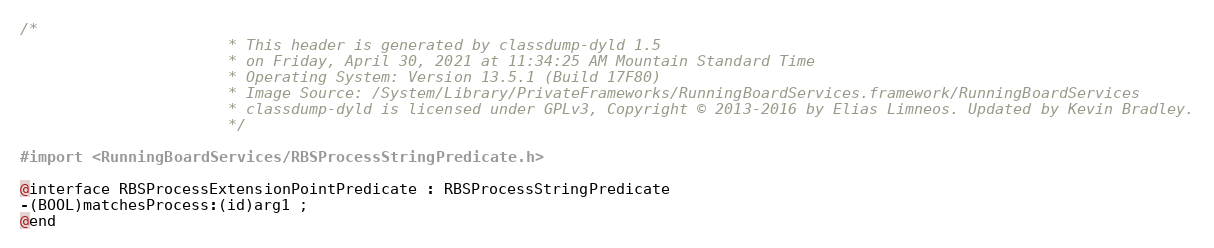<code> <loc_0><loc_0><loc_500><loc_500><_C_>/*
                       * This header is generated by classdump-dyld 1.5
                       * on Friday, April 30, 2021 at 11:34:25 AM Mountain Standard Time
                       * Operating System: Version 13.5.1 (Build 17F80)
                       * Image Source: /System/Library/PrivateFrameworks/RunningBoardServices.framework/RunningBoardServices
                       * classdump-dyld is licensed under GPLv3, Copyright © 2013-2016 by Elias Limneos. Updated by Kevin Bradley.
                       */

#import <RunningBoardServices/RBSProcessStringPredicate.h>

@interface RBSProcessExtensionPointPredicate : RBSProcessStringPredicate
-(BOOL)matchesProcess:(id)arg1 ;
@end

</code> 